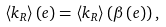<formula> <loc_0><loc_0><loc_500><loc_500>\langle k _ { R } \rangle \left ( e \right ) = \langle k _ { R } \rangle \left ( \beta \left ( e \right ) \right ) ,</formula> 